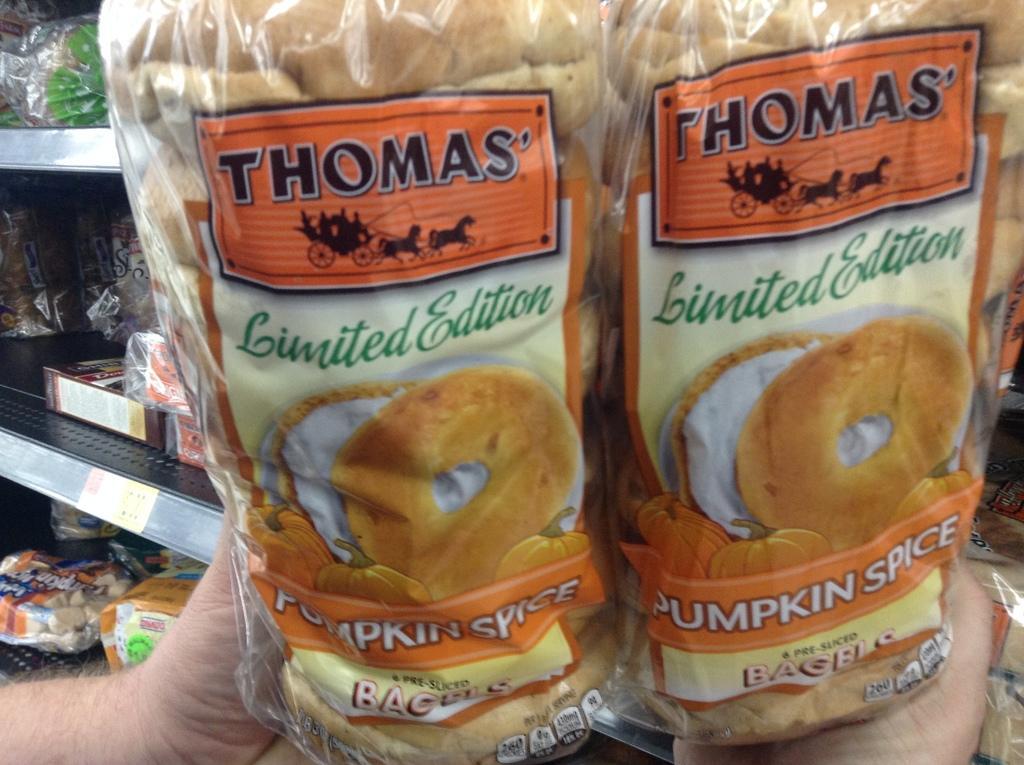Please provide a concise description of this image. In this image, I can see a person's hand holding two bread packets. These are the food items, which are packed and placed in the racks. 